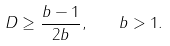Convert formula to latex. <formula><loc_0><loc_0><loc_500><loc_500>D \geq \frac { b - 1 } { 2 b } , \quad b > 1 .</formula> 